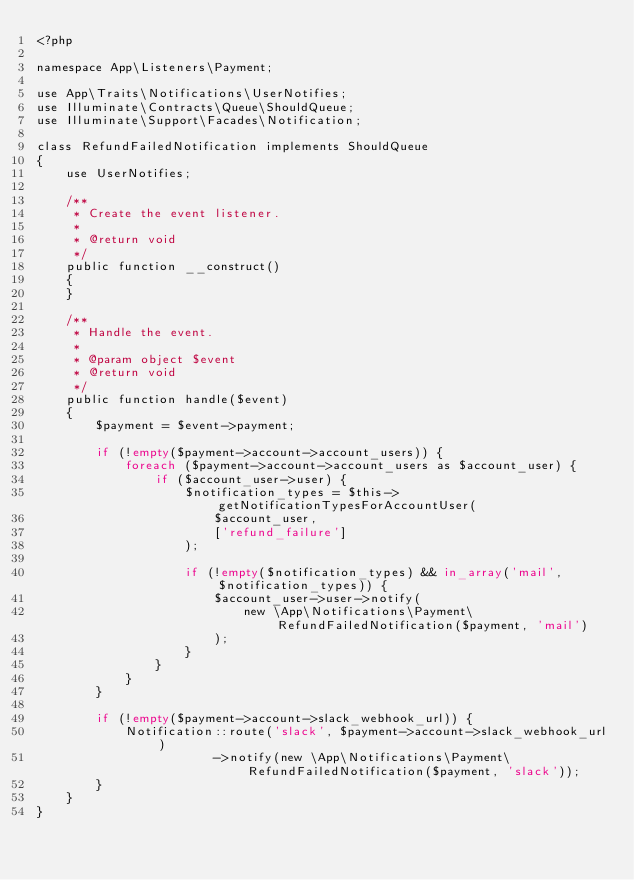<code> <loc_0><loc_0><loc_500><loc_500><_PHP_><?php

namespace App\Listeners\Payment;

use App\Traits\Notifications\UserNotifies;
use Illuminate\Contracts\Queue\ShouldQueue;
use Illuminate\Support\Facades\Notification;

class RefundFailedNotification implements ShouldQueue
{
    use UserNotifies;

    /**
     * Create the event listener.
     *
     * @return void
     */
    public function __construct()
    {
    }

    /**
     * Handle the event.
     *
     * @param object $event
     * @return void
     */
    public function handle($event)
    {
        $payment = $event->payment;

        if (!empty($payment->account->account_users)) {
            foreach ($payment->account->account_users as $account_user) {
                if ($account_user->user) {
                    $notification_types = $this->getNotificationTypesForAccountUser(
                        $account_user,
                        ['refund_failure']
                    );

                    if (!empty($notification_types) && in_array('mail', $notification_types)) {
                        $account_user->user->notify(
                            new \App\Notifications\Payment\RefundFailedNotification($payment, 'mail')
                        );
                    }
                }
            }
        }

        if (!empty($payment->account->slack_webhook_url)) {
            Notification::route('slack', $payment->account->slack_webhook_url)
                        ->notify(new \App\Notifications\Payment\RefundFailedNotification($payment, 'slack'));
        }
    }
}
</code> 